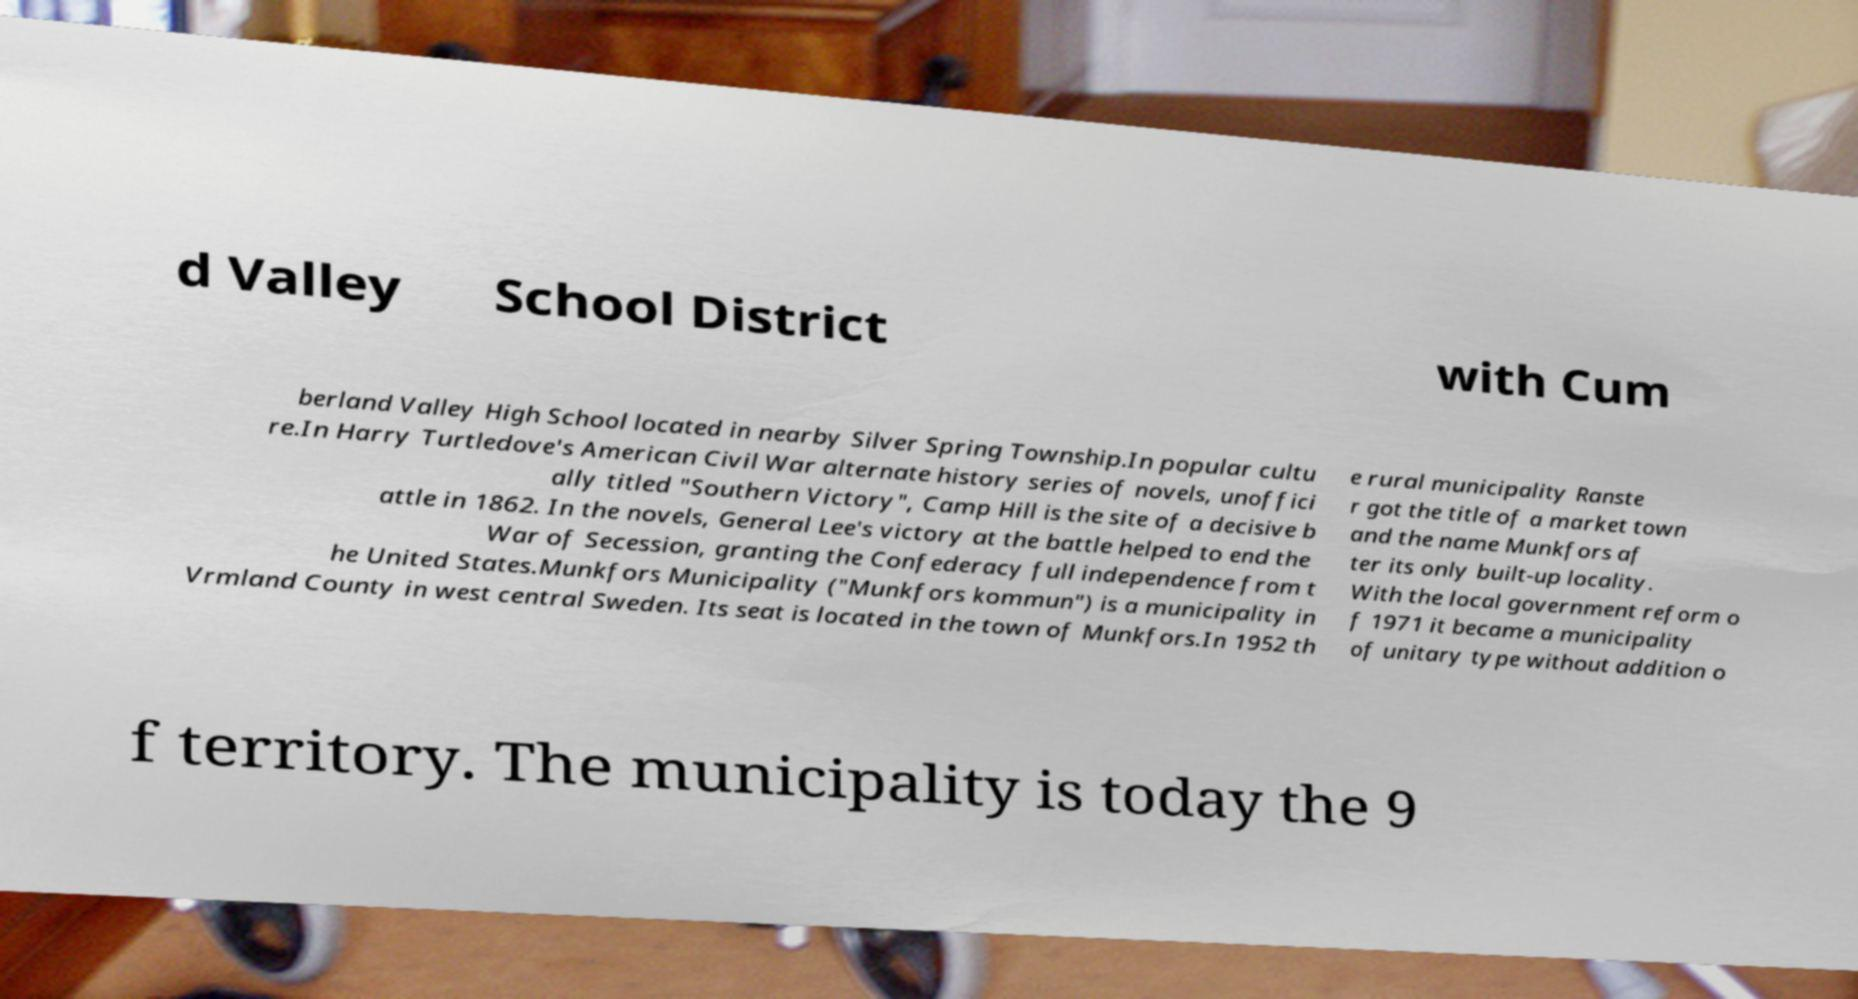For documentation purposes, I need the text within this image transcribed. Could you provide that? d Valley School District with Cum berland Valley High School located in nearby Silver Spring Township.In popular cultu re.In Harry Turtledove's American Civil War alternate history series of novels, unoffici ally titled "Southern Victory", Camp Hill is the site of a decisive b attle in 1862. In the novels, General Lee's victory at the battle helped to end the War of Secession, granting the Confederacy full independence from t he United States.Munkfors Municipality ("Munkfors kommun") is a municipality in Vrmland County in west central Sweden. Its seat is located in the town of Munkfors.In 1952 th e rural municipality Ranste r got the title of a market town and the name Munkfors af ter its only built-up locality. With the local government reform o f 1971 it became a municipality of unitary type without addition o f territory. The municipality is today the 9 